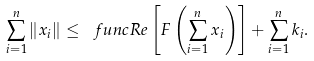<formula> <loc_0><loc_0><loc_500><loc_500>\sum _ { i = 1 } ^ { n } \left \| x _ { i } \right \| \leq \ f u n c { R e } \left [ F \left ( \sum _ { i = 1 } ^ { n } x _ { i } \right ) \right ] + \sum _ { i = 1 } ^ { n } k _ { i } .</formula> 